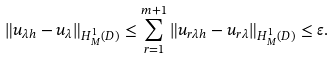<formula> <loc_0><loc_0><loc_500><loc_500>\| u _ { \lambda h } - u _ { \lambda } \| _ { H ^ { 1 } _ { M } ( D ) } \leq \sum _ { r = 1 } ^ { m + 1 } \| u _ { r \lambda h } - u _ { r \lambda } \| _ { H ^ { 1 } _ { M } ( D ) } \leq \varepsilon .</formula> 